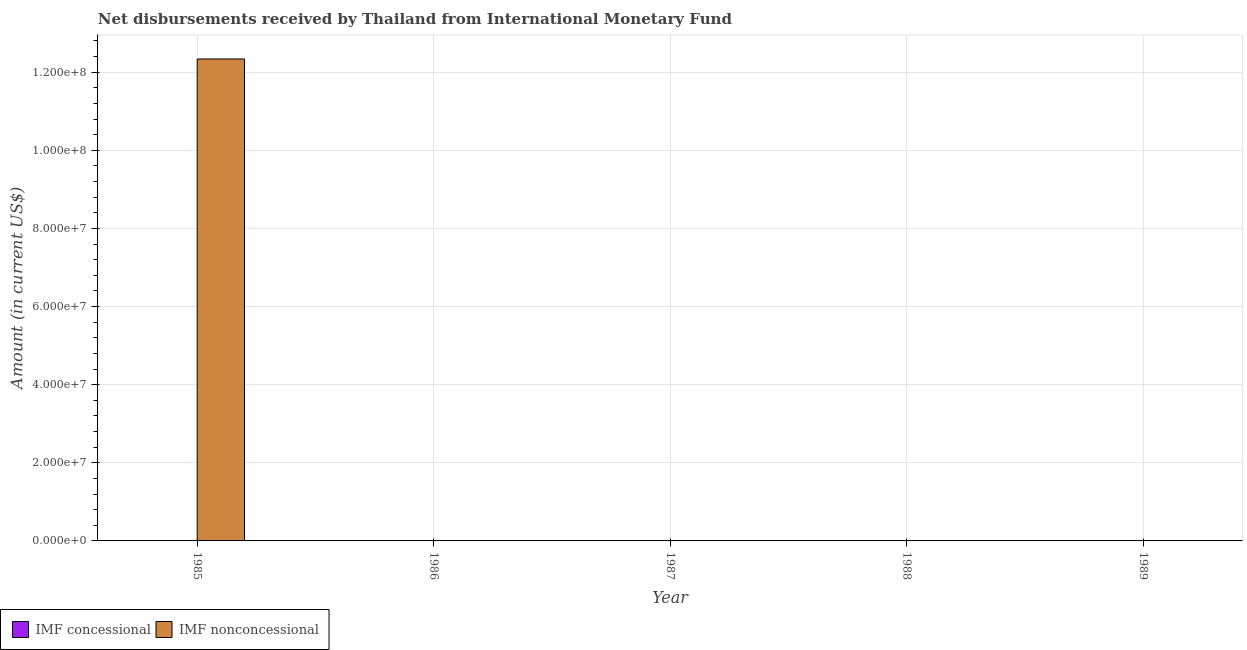How many different coloured bars are there?
Your answer should be very brief. 1. Are the number of bars on each tick of the X-axis equal?
Your answer should be compact. No. How many bars are there on the 3rd tick from the left?
Your answer should be compact. 0. How many bars are there on the 4th tick from the right?
Offer a terse response. 0. In how many cases, is the number of bars for a given year not equal to the number of legend labels?
Provide a short and direct response. 5. What is the net concessional disbursements from imf in 1985?
Make the answer very short. 0. Across all years, what is the maximum net non concessional disbursements from imf?
Offer a terse response. 1.23e+08. What is the total net non concessional disbursements from imf in the graph?
Your answer should be compact. 1.23e+08. What is the difference between the net concessional disbursements from imf in 1988 and the net non concessional disbursements from imf in 1987?
Ensure brevity in your answer.  0. What is the average net non concessional disbursements from imf per year?
Offer a very short reply. 2.47e+07. In the year 1985, what is the difference between the net non concessional disbursements from imf and net concessional disbursements from imf?
Provide a short and direct response. 0. In how many years, is the net non concessional disbursements from imf greater than 64000000 US$?
Provide a short and direct response. 1. What is the difference between the highest and the lowest net non concessional disbursements from imf?
Offer a very short reply. 1.23e+08. In how many years, is the net concessional disbursements from imf greater than the average net concessional disbursements from imf taken over all years?
Your response must be concise. 0. Are all the bars in the graph horizontal?
Keep it short and to the point. No. Does the graph contain grids?
Your response must be concise. Yes. Where does the legend appear in the graph?
Offer a very short reply. Bottom left. What is the title of the graph?
Provide a succinct answer. Net disbursements received by Thailand from International Monetary Fund. Does "Primary income" appear as one of the legend labels in the graph?
Keep it short and to the point. No. What is the label or title of the X-axis?
Your response must be concise. Year. What is the Amount (in current US$) of IMF concessional in 1985?
Your answer should be very brief. 0. What is the Amount (in current US$) in IMF nonconcessional in 1985?
Your answer should be very brief. 1.23e+08. What is the Amount (in current US$) in IMF concessional in 1986?
Your answer should be compact. 0. What is the Amount (in current US$) of IMF concessional in 1987?
Provide a short and direct response. 0. What is the Amount (in current US$) in IMF nonconcessional in 1987?
Keep it short and to the point. 0. What is the Amount (in current US$) in IMF concessional in 1989?
Your response must be concise. 0. What is the Amount (in current US$) of IMF nonconcessional in 1989?
Provide a short and direct response. 0. Across all years, what is the maximum Amount (in current US$) of IMF nonconcessional?
Offer a very short reply. 1.23e+08. Across all years, what is the minimum Amount (in current US$) of IMF nonconcessional?
Give a very brief answer. 0. What is the total Amount (in current US$) of IMF nonconcessional in the graph?
Provide a short and direct response. 1.23e+08. What is the average Amount (in current US$) of IMF nonconcessional per year?
Offer a terse response. 2.47e+07. What is the difference between the highest and the lowest Amount (in current US$) in IMF nonconcessional?
Your answer should be compact. 1.23e+08. 